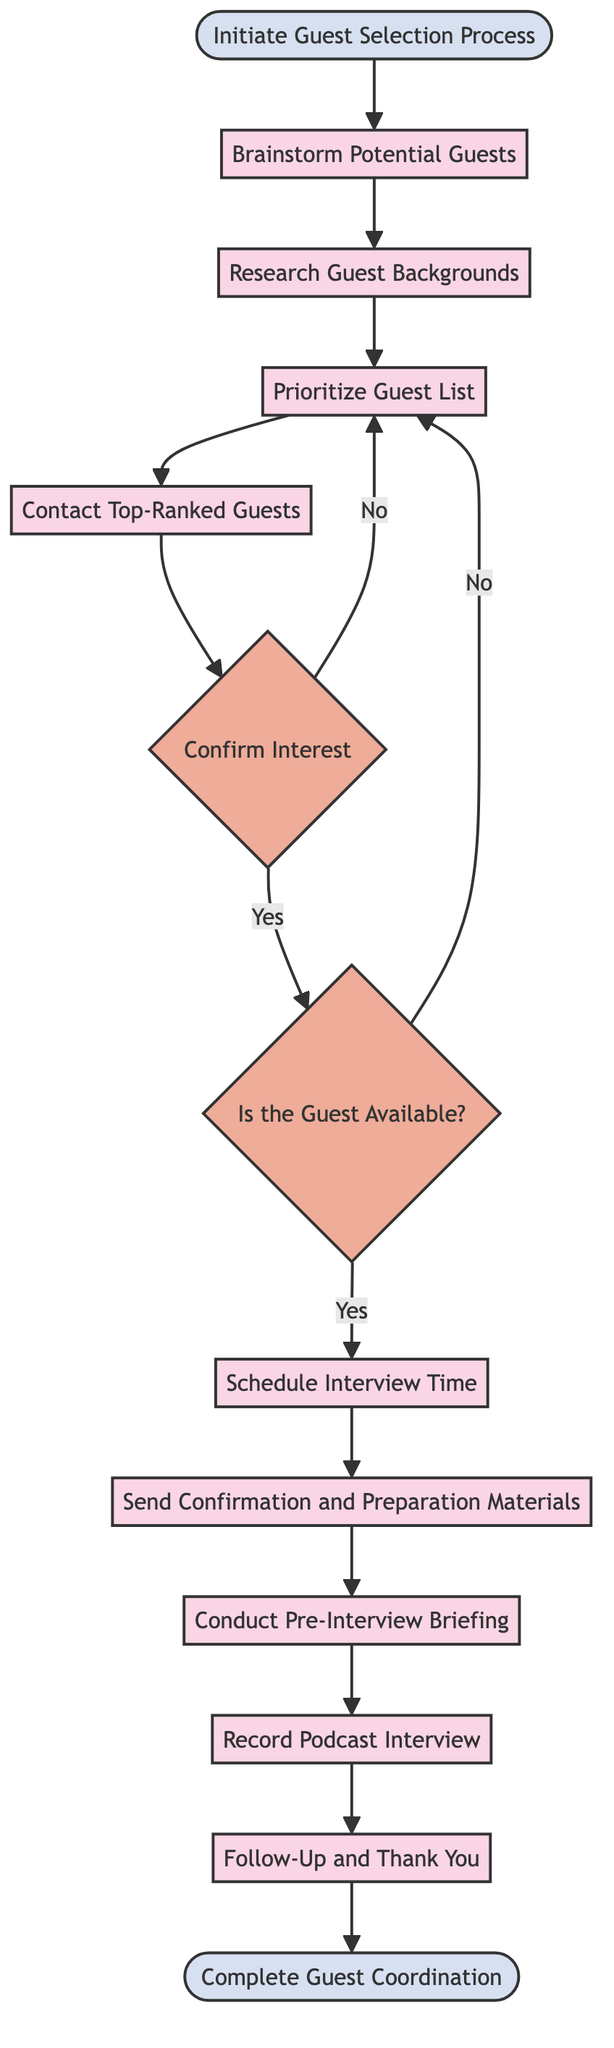What is the starting point of the diagram? The starting point of the diagram is labeled as "Initiate Guest Selection Process," which indicates where the process begins.
Answer: Initiate Guest Selection Process How many decision points are there in the diagram? There are two decision points in the diagram, identified as "Is the Guest Available?" and "Confirm Interest."
Answer: 2 What is the last activity before the end of the process? The last activity before reaching the end of the process is "Follow-Up and Thank You," which is the concluding step.
Answer: Follow-Up and Thank You What occurs after prioritizing the guest list? After prioritizing the guest list, the next step is to contact the top-ranked guests to gauge their interest in participating, which is indicated in the flow.
Answer: Contact Top-Ranked Guests What happens if the guest is not available? If the guest is not available, the flow goes back to the "Prioritize Guest List" activity to reconsider other potential guests.
Answer: Reprioritize guest list How many total activities are there in the diagram? The diagram contains a total of nine activities that represent the steps taken during the guest selection process.
Answer: 9 What is the purpose of the "Confirm Interest" decision point? The purpose of the "Confirm Interest" decision point is to determine if the contacted top-ranked guests are interested in participating in the podcast interview.
Answer: To ensure interest What action is taken if the guest confirms their availability? If the guest confirms their availability, the next action is to schedule the interview time, as shown in the flow of the diagram.
Answer: Schedule Interview Time 